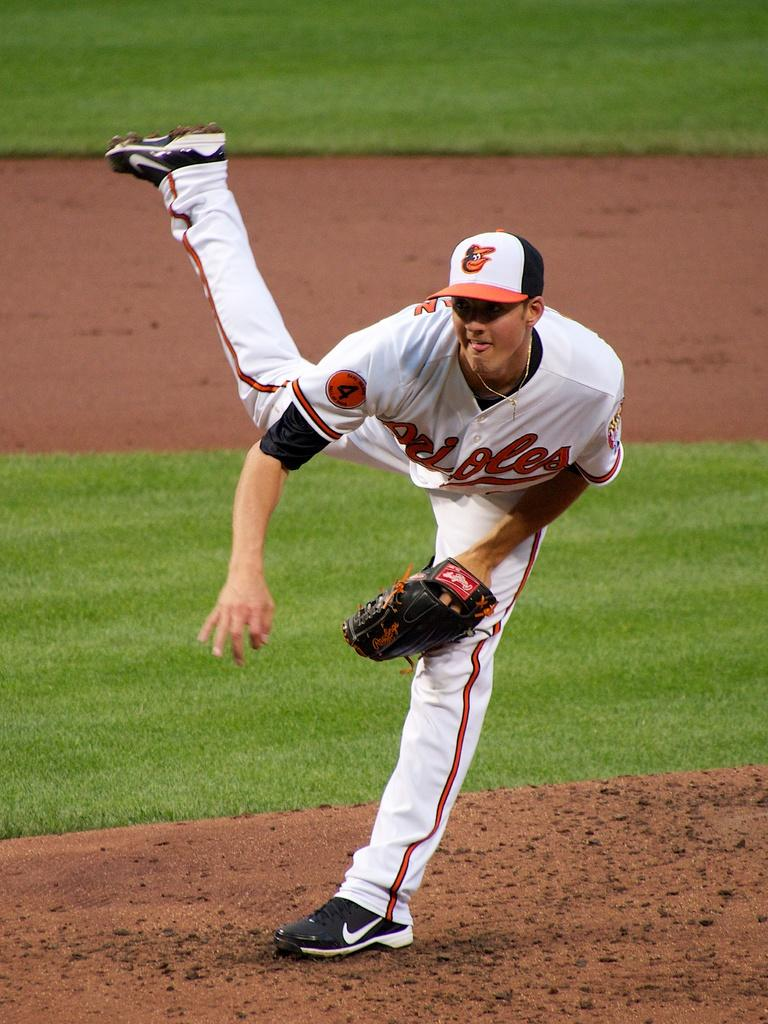<image>
Relay a brief, clear account of the picture shown. a player with the name Orioles on their jersey 